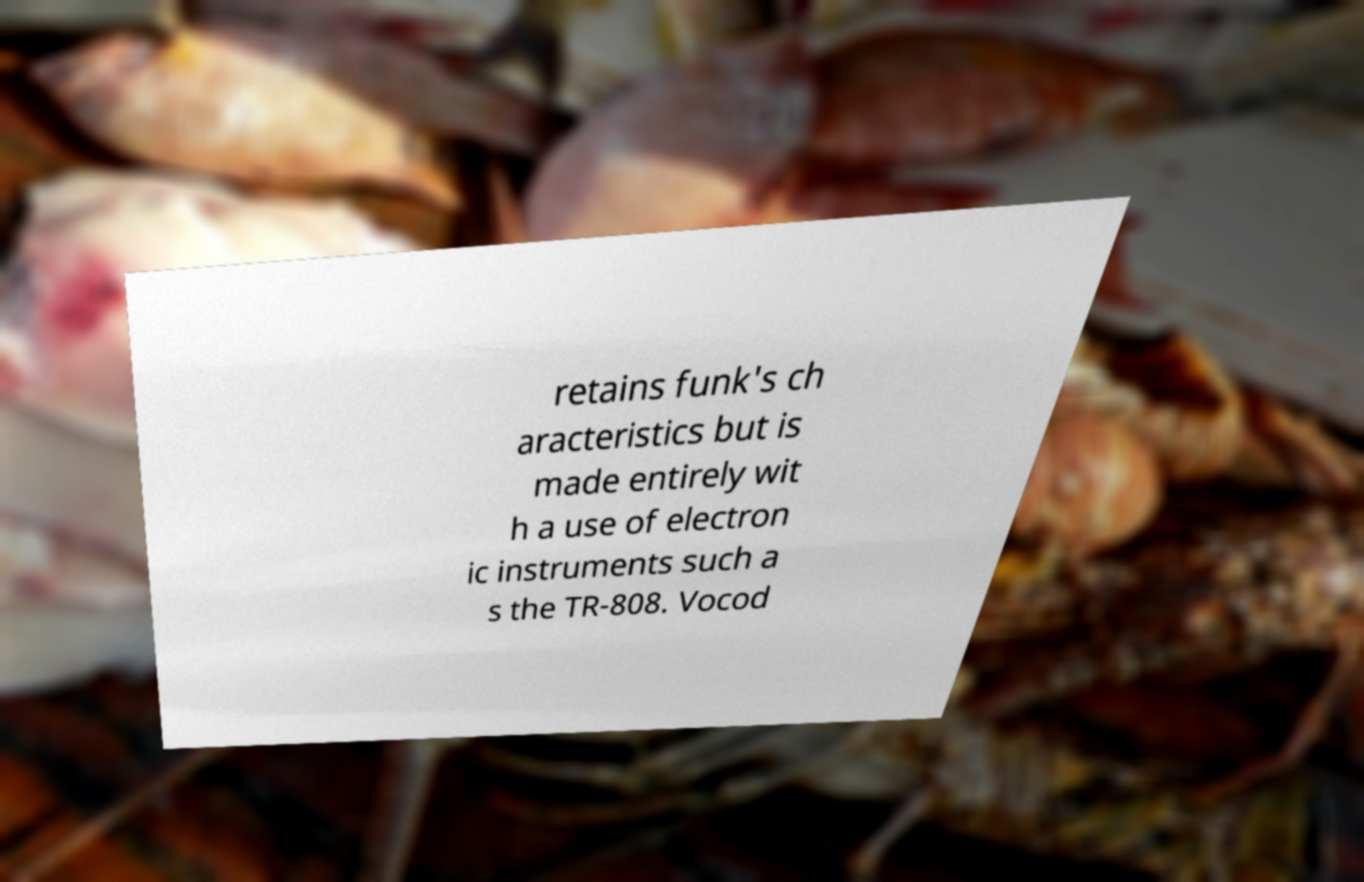Please read and relay the text visible in this image. What does it say? retains funk's ch aracteristics but is made entirely wit h a use of electron ic instruments such a s the TR-808. Vocod 